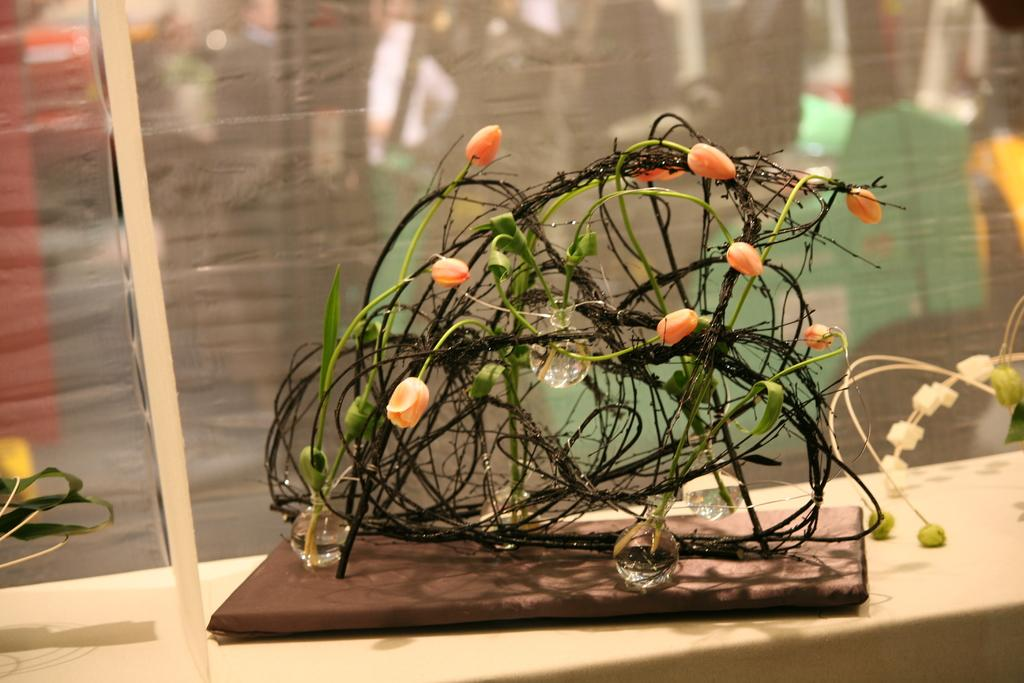What type of object is featured in the image? There is a decorative object in the image. What are some characteristics of the decorative object? The decorative object has bulbs and flower buds. Can you describe the background of the image? The background of the image is blurred. Where is the toothbrush stored in the image? There is no toothbrush present in the image. What type of sack can be seen in the image? There is no sack present in the image. 